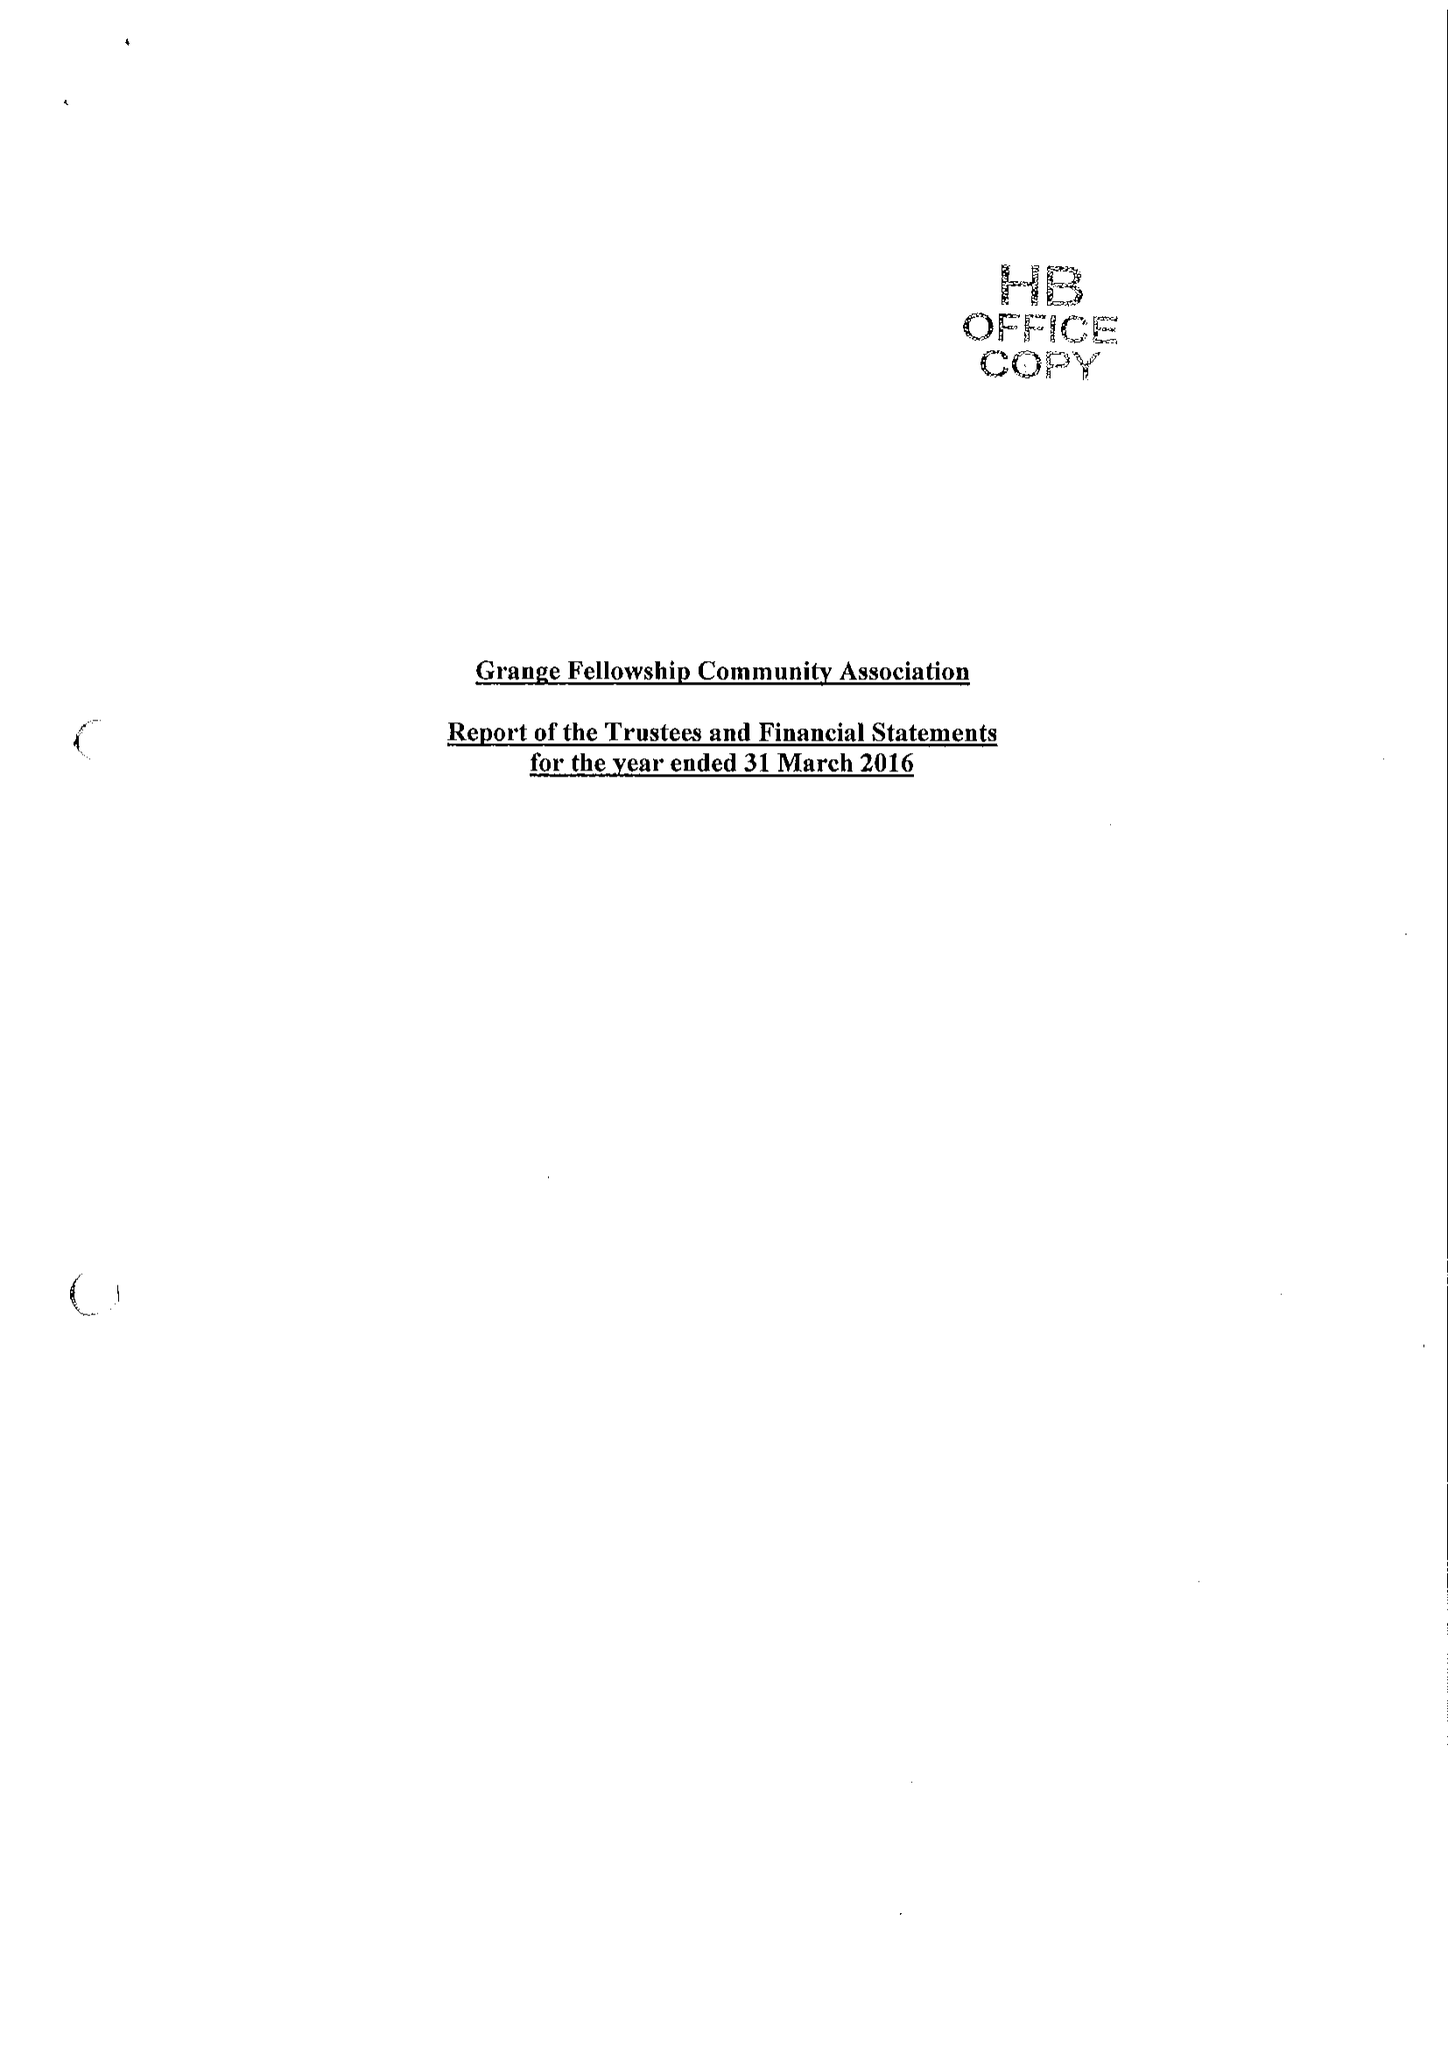What is the value for the address__street_line?
Answer the question using a single word or phrase. MIDDLEFIELDS 